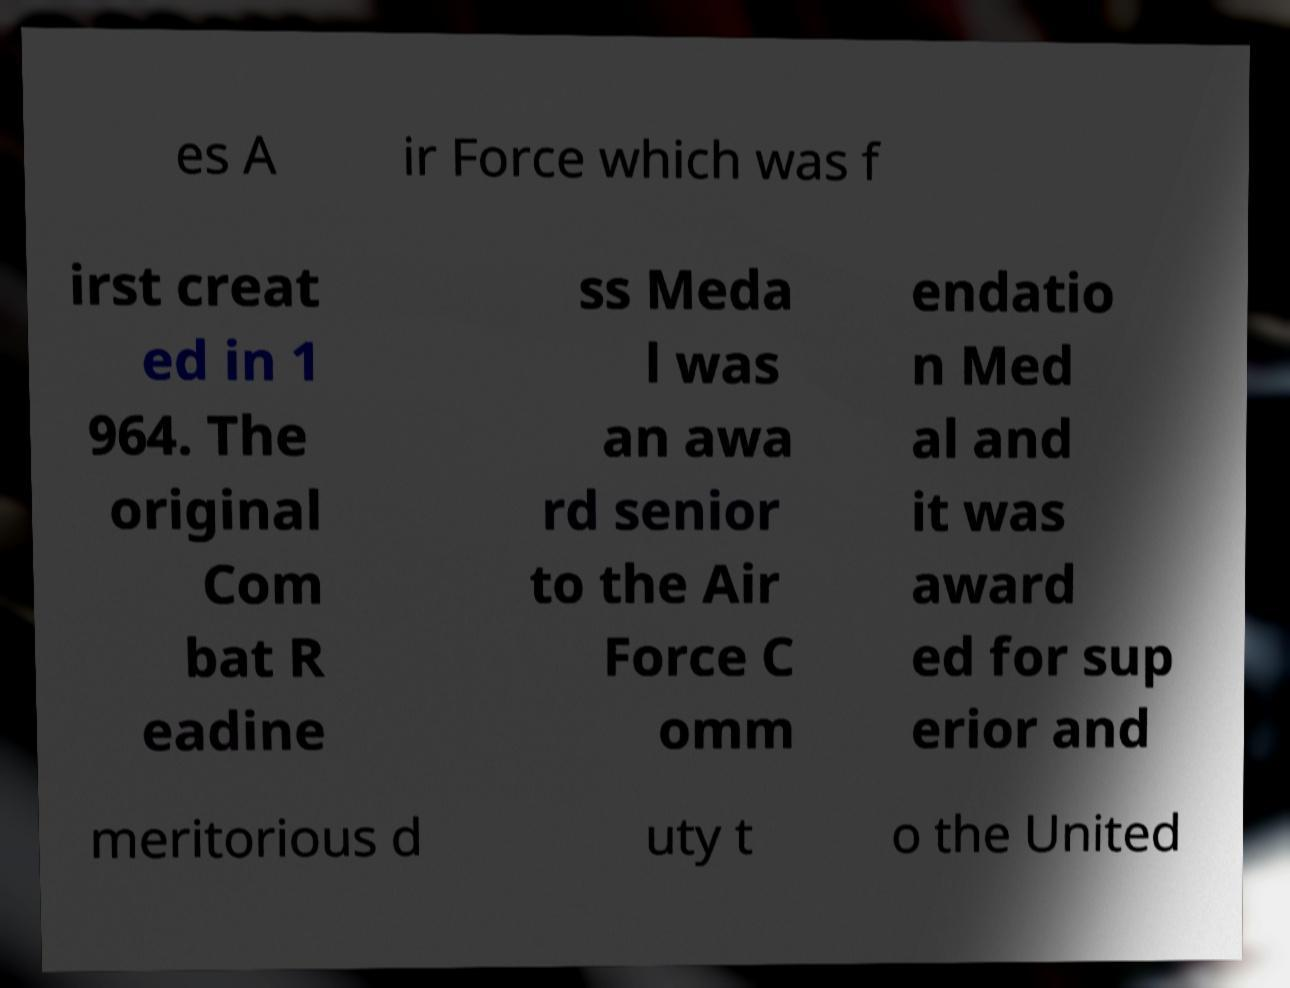There's text embedded in this image that I need extracted. Can you transcribe it verbatim? es A ir Force which was f irst creat ed in 1 964. The original Com bat R eadine ss Meda l was an awa rd senior to the Air Force C omm endatio n Med al and it was award ed for sup erior and meritorious d uty t o the United 